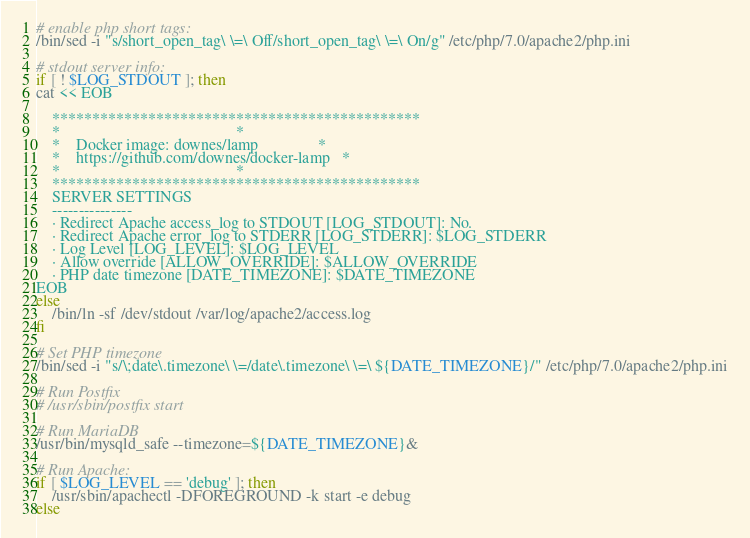Convert code to text. <code><loc_0><loc_0><loc_500><loc_500><_Bash_>
# enable php short tags:
/bin/sed -i "s/short_open_tag\ \=\ Off/short_open_tag\ \=\ On/g" /etc/php/7.0/apache2/php.ini

# stdout server info:
if [ ! $LOG_STDOUT ]; then
cat << EOB
    
    **********************************************
    *                                            *
    *    Docker image: downes/lamp               *
    *    https://github.com/downes/docker-lamp   *
    *                                            *
    **********************************************
    SERVER SETTINGS
    ---------------
    · Redirect Apache access_log to STDOUT [LOG_STDOUT]: No.
    · Redirect Apache error_log to STDERR [LOG_STDERR]: $LOG_STDERR
    · Log Level [LOG_LEVEL]: $LOG_LEVEL
    · Allow override [ALLOW_OVERRIDE]: $ALLOW_OVERRIDE
    · PHP date timezone [DATE_TIMEZONE]: $DATE_TIMEZONE
EOB
else
    /bin/ln -sf /dev/stdout /var/log/apache2/access.log
fi

# Set PHP timezone
/bin/sed -i "s/\;date\.timezone\ \=/date\.timezone\ \=\ ${DATE_TIMEZONE}/" /etc/php/7.0/apache2/php.ini

# Run Postfix
# /usr/sbin/postfix start

# Run MariaDB
/usr/bin/mysqld_safe --timezone=${DATE_TIMEZONE}&

# Run Apache:
if [ $LOG_LEVEL == 'debug' ]; then
    /usr/sbin/apachectl -DFOREGROUND -k start -e debug
else</code> 